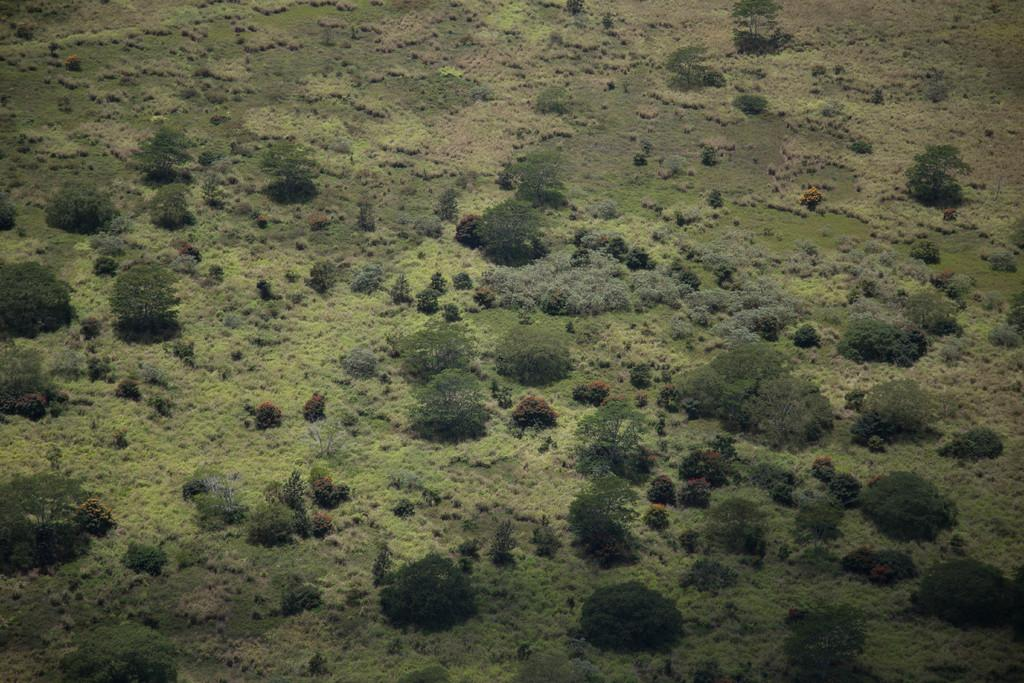What type of vegetation can be seen in the image? There are trees and plants in the image. Can you describe the specific types of plants in the image? Unfortunately, the specific types of plants cannot be determined from the image alone. What nation is represented by the pen in the image? There is no pen present in the image, so it is not possible to determine which nation might be represented. 